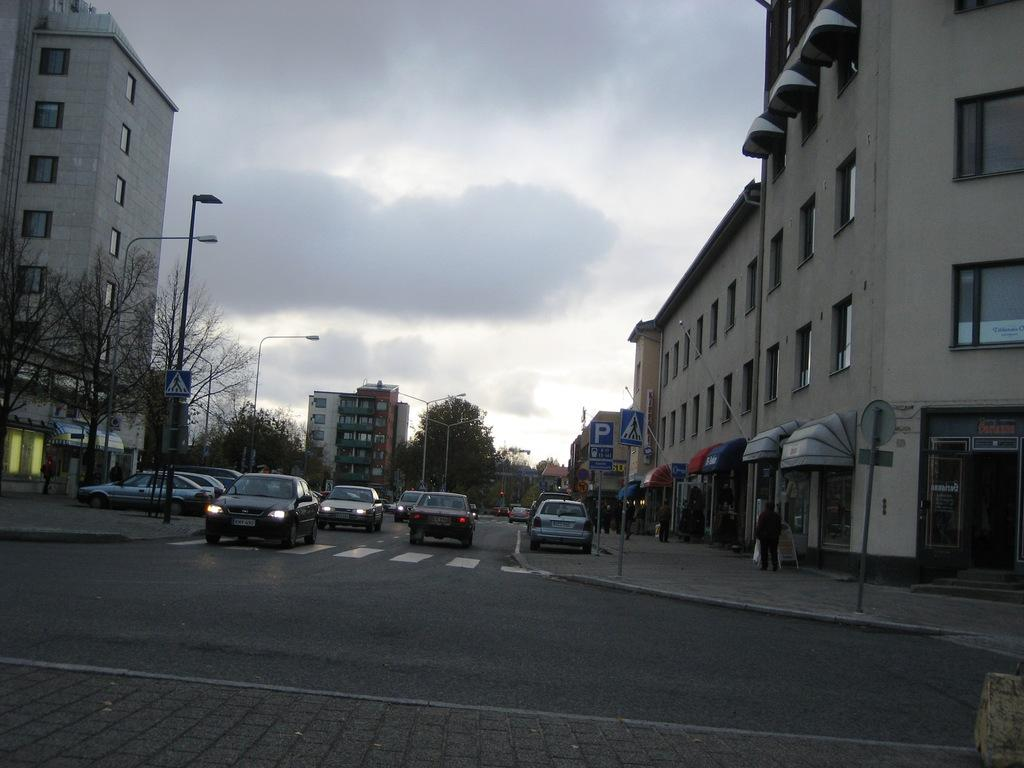What can be seen on the road in the image? There are vehicles on the road in the image. What structures are visible in the image? There are buildings visible in the image. What type of lighting is present in the image? Street lights are present in the image. What else can be seen in the image besides vehicles and buildings? Poles and trees are visible in the image. What is visible in the background of the image? The sky is visible in the image. What story is being told by the vehicles in the image? There is no story being told by the vehicles in the image; they are simply moving along the road. How many balls can be seen in the image? There are no balls present in the image. 